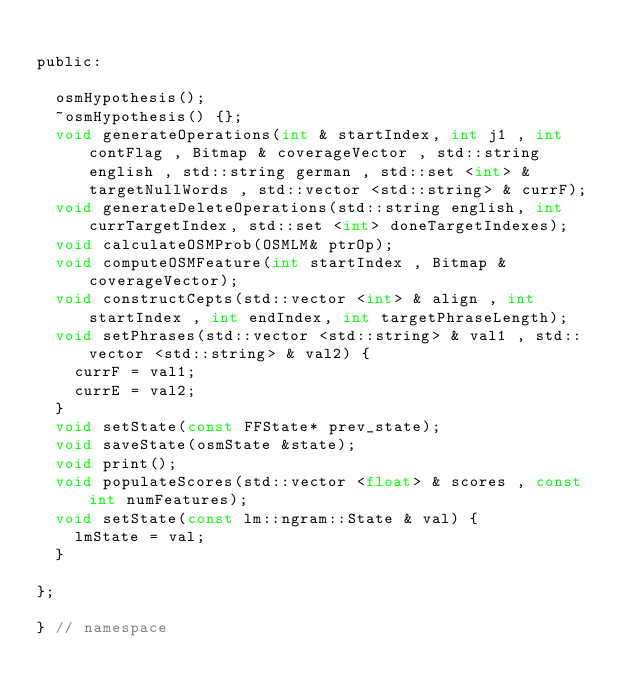<code> <loc_0><loc_0><loc_500><loc_500><_C_>
public:

  osmHypothesis();
  ~osmHypothesis() {};
  void generateOperations(int & startIndex, int j1 , int contFlag , Bitmap & coverageVector , std::string english , std::string german , std::set <int> & targetNullWords , std::vector <std::string> & currF);
  void generateDeleteOperations(std::string english, int currTargetIndex, std::set <int> doneTargetIndexes);
  void calculateOSMProb(OSMLM& ptrOp);
  void computeOSMFeature(int startIndex , Bitmap & coverageVector);
  void constructCepts(std::vector <int> & align , int startIndex , int endIndex, int targetPhraseLength);
  void setPhrases(std::vector <std::string> & val1 , std::vector <std::string> & val2) {
    currF = val1;
    currE = val2;
  }
  void setState(const FFState* prev_state);
  void saveState(osmState &state);
  void print();
  void populateScores(std::vector <float> & scores , const int numFeatures);
  void setState(const lm::ngram::State & val) {
    lmState = val;
  }

};

} // namespace



</code> 